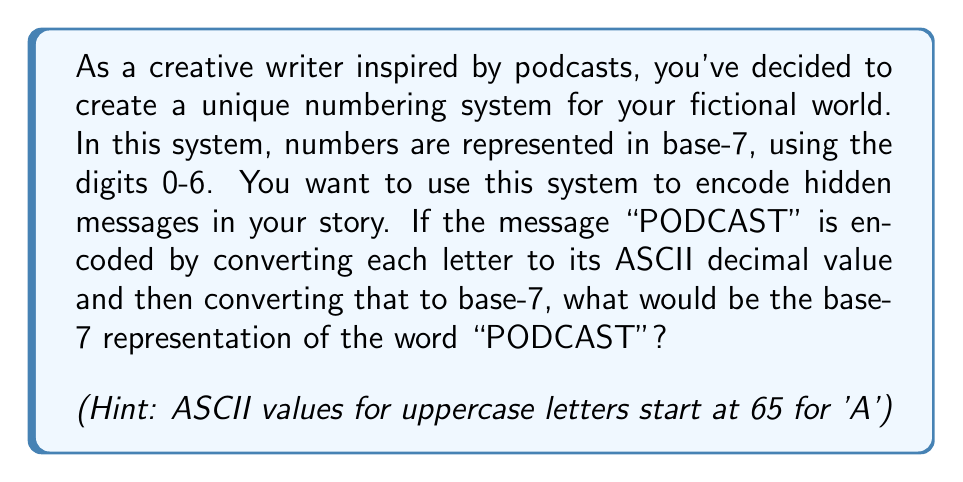Solve this math problem. Let's approach this step-by-step:

1) First, we need to convert each letter to its ASCII decimal value:
   P: 80
   O: 79
   D: 68
   C: 67
   A: 65
   S: 83
   T: 84

2) Now, we need to convert each of these decimal values to base-7. To do this, we divide by 7 repeatedly and read the remainders from bottom to top:

   For P (80):
   $$ 80 \div 7 = 11 \text{ remainder } 3 $$
   $$ 11 \div 7 = 1 \text{ remainder } 4 $$
   $$ 1 \div 7 = 0 \text{ remainder } 1 $$
   So, 80 in base-7 is 143

   For O (79):
   $$ 79 \div 7 = 11 \text{ remainder } 2 $$
   $$ 11 \div 7 = 1 \text{ remainder } 4 $$
   $$ 1 \div 7 = 0 \text{ remainder } 1 $$
   So, 79 in base-7 is 142

   For D (68):
   $$ 68 \div 7 = 9 \text{ remainder } 5 $$
   $$ 9 \div 7 = 1 \text{ remainder } 2 $$
   $$ 1 \div 7 = 0 \text{ remainder } 1 $$
   So, 68 in base-7 is 125

   For C (67):
   $$ 67 \div 7 = 9 \text{ remainder } 4 $$
   $$ 9 \div 7 = 1 \text{ remainder } 2 $$
   $$ 1 \div 7 = 0 \text{ remainder } 1 $$
   So, 67 in base-7 is 124

   For A (65):
   $$ 65 \div 7 = 9 \text{ remainder } 2 $$
   $$ 9 \div 7 = 1 \text{ remainder } 2 $$
   $$ 1 \div 7 = 0 \text{ remainder } 1 $$
   So, 65 in base-7 is 122

   For S (83):
   $$ 83 \div 7 = 11 \text{ remainder } 6 $$
   $$ 11 \div 7 = 1 \text{ remainder } 4 $$
   $$ 1 \div 7 = 0 \text{ remainder } 1 $$
   So, 83 in base-7 is 146

   For T (84):
   $$ 84 \div 7 = 12 \text{ remainder } 0 $$
   $$ 12 \div 7 = 1 \text{ remainder } 5 $$
   $$ 1 \div 7 = 0 \text{ remainder } 1 $$
   So, 84 in base-7 is 150

3) Now we have the base-7 representation for each letter. We can combine these to get the final result.
Answer: The base-7 representation of "PODCAST" is: 143 142 125 124 122 146 150 